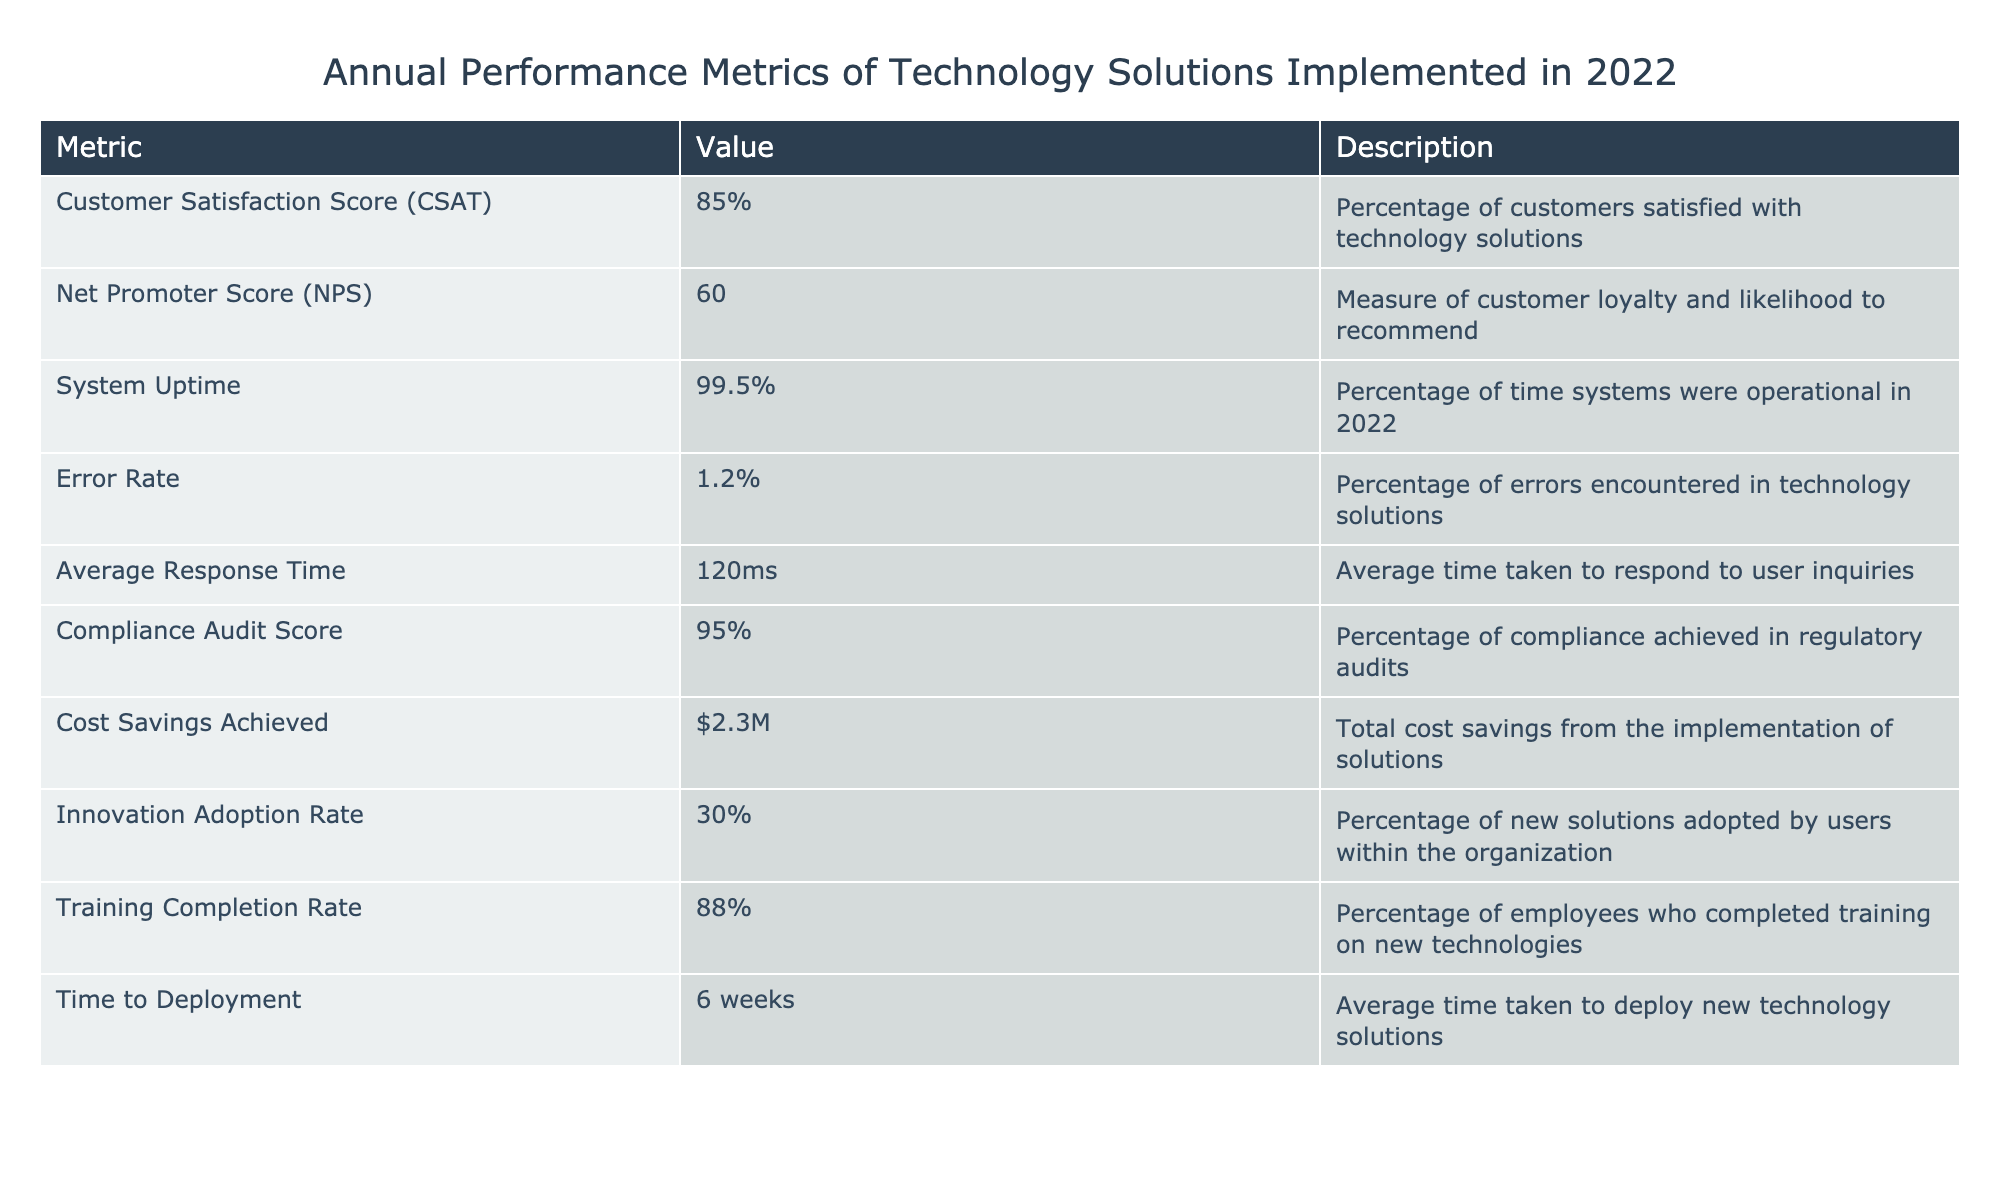What was the Customer Satisfaction Score in 2022? The table lists a specific value for the Customer Satisfaction Score, which is 85%.
Answer: 85% What is the Error Rate reported for the technology solutions? The table shows that the Error Rate is 1.2%.
Answer: 1.2% What percentage of employees completed training on new technologies? According to the table, the Training Completion Rate is 88%.
Answer: 88% Is the Compliance Audit Score greater than the Customer Satisfaction Score? The Compliance Audit Score is 95% and the Customer Satisfaction Score is 85%, so 95% is greater than 85%.
Answer: Yes What is the difference between the Compliance Audit Score and the Net Promoter Score? The Compliance Audit Score is 95% and the Net Promoter Score is 60. The difference is 95 - 60 = 35.
Answer: 35 What is the average time to deploy new technology solutions and how does it compare to the Average Response Time? The Time to Deployment is 6 weeks (which equals 42 days) and the Average Response Time is 120 milliseconds. To compare, it's necessary to convert 6 weeks into milliseconds, which is a larger number, indicating it takes much longer to deploy compared to responding to inquiries.
Answer: Deployment takes longer How do the scores for Customer Satisfaction and Innovation Adoption Rate compare? The Customer Satisfaction Score is 85% and the Innovation Adoption Rate is 30%. Since 85% is noticeably higher than 30%, there is a significant difference.
Answer: Customer Satisfaction is higher What percentage of system uptime was achieved in 2022? The table states that the System Uptime was 99.5%.
Answer: 99.5% What sum of cost savings was achieved from the implementation of technology solutions? The total Cost Savings Achieved reported is $2.3 million, reflecting the financial impact of technology implementations.
Answer: $2.3M 